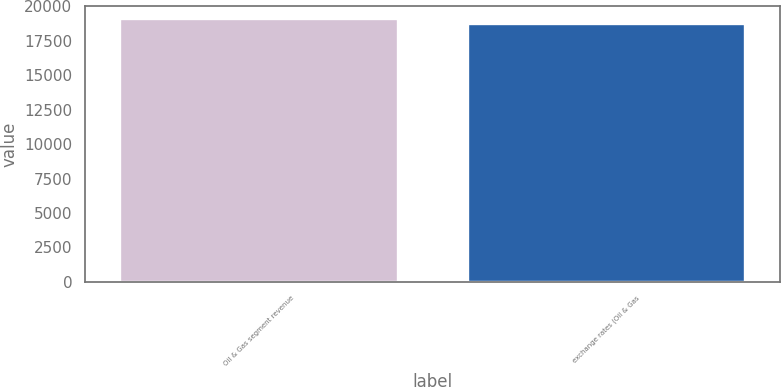<chart> <loc_0><loc_0><loc_500><loc_500><bar_chart><fcel>Oil & Gas segment revenue<fcel>exchange rates (Oil & Gas<nl><fcel>19085<fcel>18735<nl></chart> 